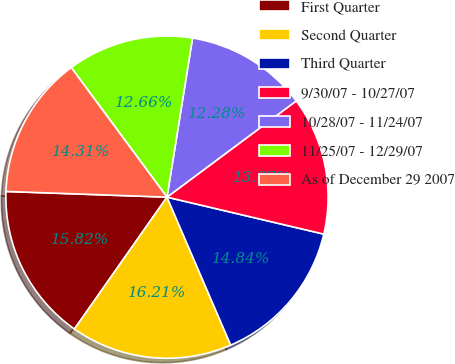<chart> <loc_0><loc_0><loc_500><loc_500><pie_chart><fcel>First Quarter<fcel>Second Quarter<fcel>Third Quarter<fcel>9/30/07 - 10/27/07<fcel>10/28/07 - 11/24/07<fcel>11/25/07 - 12/29/07<fcel>As of December 29 2007<nl><fcel>15.82%<fcel>16.21%<fcel>14.84%<fcel>13.87%<fcel>12.28%<fcel>12.66%<fcel>14.31%<nl></chart> 